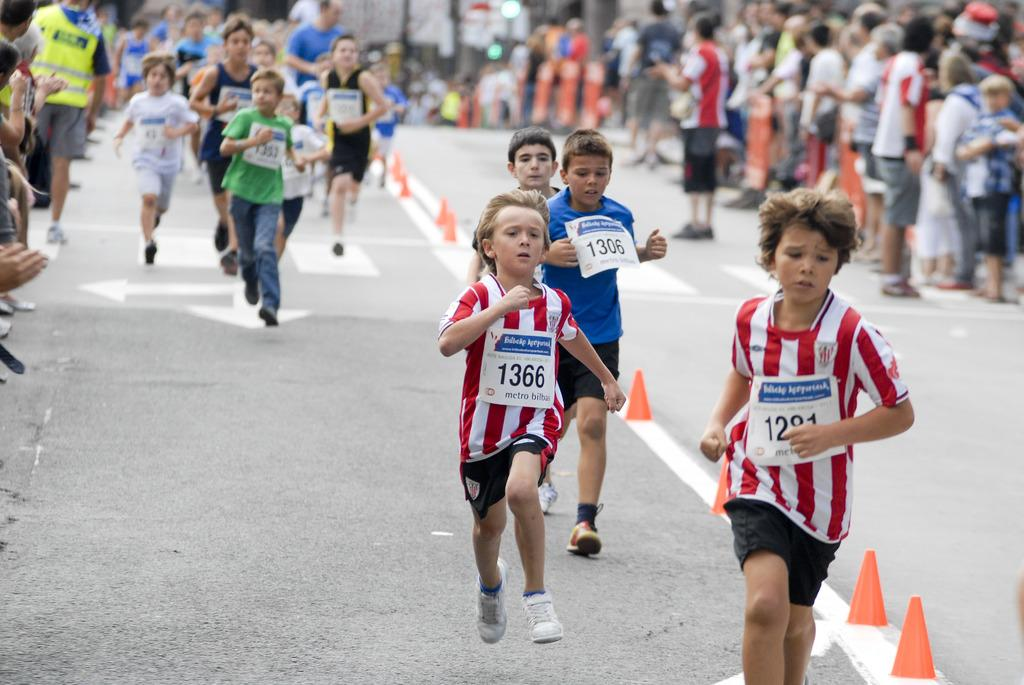What is the main subject of the image? The main subject of the image is a group of people. What are the kids in the image doing? The kids are running on the road. What objects are in the middle of the road? There are blocks in the middle of the road. What type of sheet is being used to cover the blocks in the image? There is no sheet present in the image; the blocks are visible and not covered. 